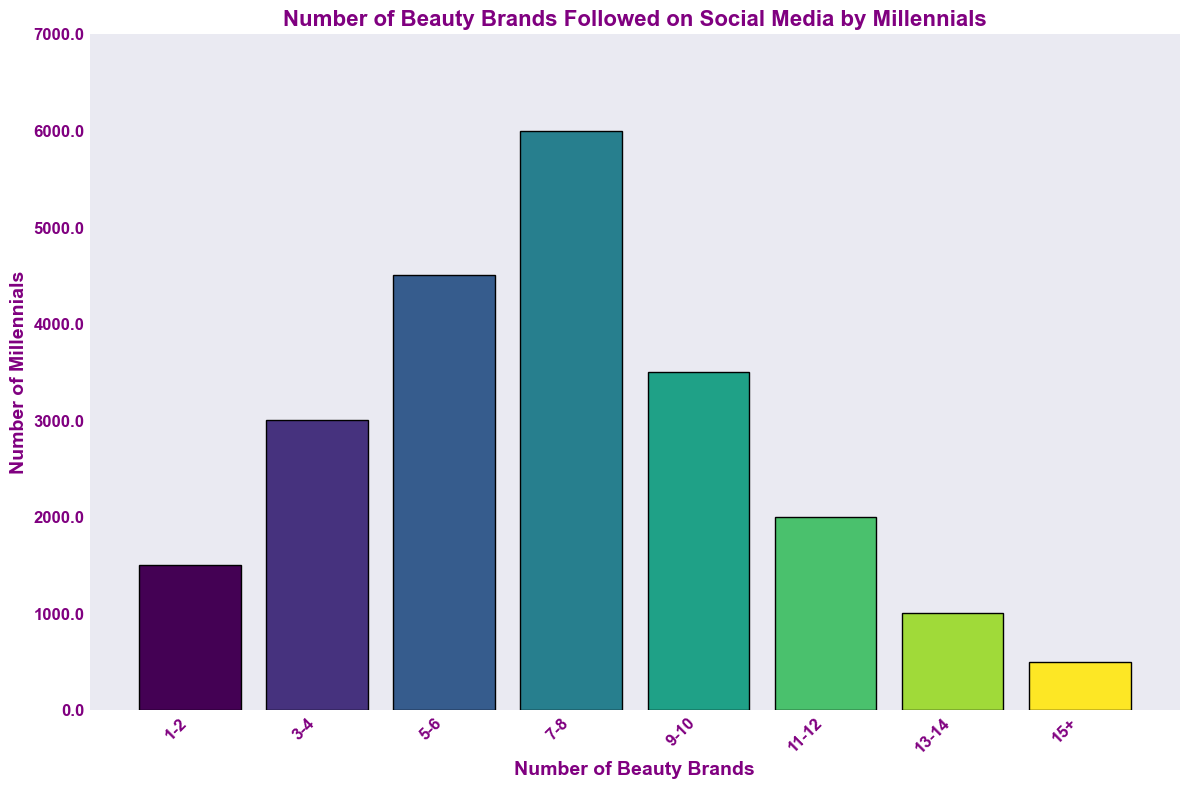Which range of beauty brands followed is the most popular among millennials? To find the most popular range, look for the bar with the highest height on the chart. The 7-8 range has the tallest bar.
Answer: 7-8 How many millennials follow 5-6 beauty brands on social media? Locate the bar labeled 5-6 and check its height on the y-axis. The height is 4500 millennials.
Answer: 4500 What is the total number of millennials who follow 13 or more beauty brands? Sum the heights of the bars labeled 13-14 and 15+. For 13-14, it's 1000, and for 15+, it's 500. Thus, 1000 + 500 = 1500 millennials.
Answer: 1500 Which range has more followers: 1-2 or 11-12 beauty brands? Compare the heights of the bars labeled 1-2 and 11-12. 1-2 has 1500 followers, and 11-12 has 2000 followers.
Answer: 11-12 What is the combined number of millennials who follow 3-4 and 9-10 beauty brands? Add the heights of the bars labeled 3-4 and 9-10. 3-4 has 3000 followers, and 9-10 has 3500 followers. Therefore, 3000 + 3500 = 6500 millennials.
Answer: 6500 Which range has the least number of followers? Look for the shortest bar on the chart, which corresponds to the 15+ range.
Answer: 15+ Are there more millennials following 7-8 beauty brands than the combined total of those following 1-2 and 3-4 beauty brands? First, sum the followers for 1-2 and 3-4, which is 1500 + 3000 = 4500. Compare this with the followers of the 7-8 range, which has 6000. Since 6000 is greater than 4500, the answer is yes.
Answer: Yes What is the difference in the number of millennials following 9-10 beauty brands compared to those following 11-12 beauty brands? Subtract the number following 11-12 from the number following 9-10. So, 3500 - 2000 = 1500 millennials.
Answer: 1500 What is the average number of millennials following the beauty brands in the 1-2, 3-4, and 5-6 ranges? Add the numbers for 1-2, 3-4, and 5-6 and divide by 3. (1500 + 3000 + 4500) / 3 = 3000 millennials.
Answer: 3000 Which range of beauty brands followed has a height that is double that of the 5-6 range? Identify the height of the 5-6 range, which is 4500. Look for a bar with twice this height, which would be 9000, and no such range exists.
Answer: None 